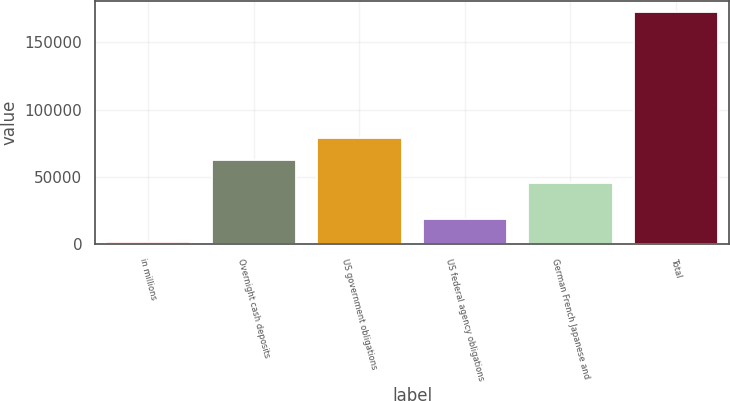Convert chart to OTSL. <chart><loc_0><loc_0><loc_500><loc_500><bar_chart><fcel>in millions<fcel>Overnight cash deposits<fcel>US government obligations<fcel>US federal agency obligations<fcel>German French Japanese and<fcel>Total<nl><fcel>2012<fcel>62178.3<fcel>79186.6<fcel>19020.3<fcel>45170<fcel>172095<nl></chart> 